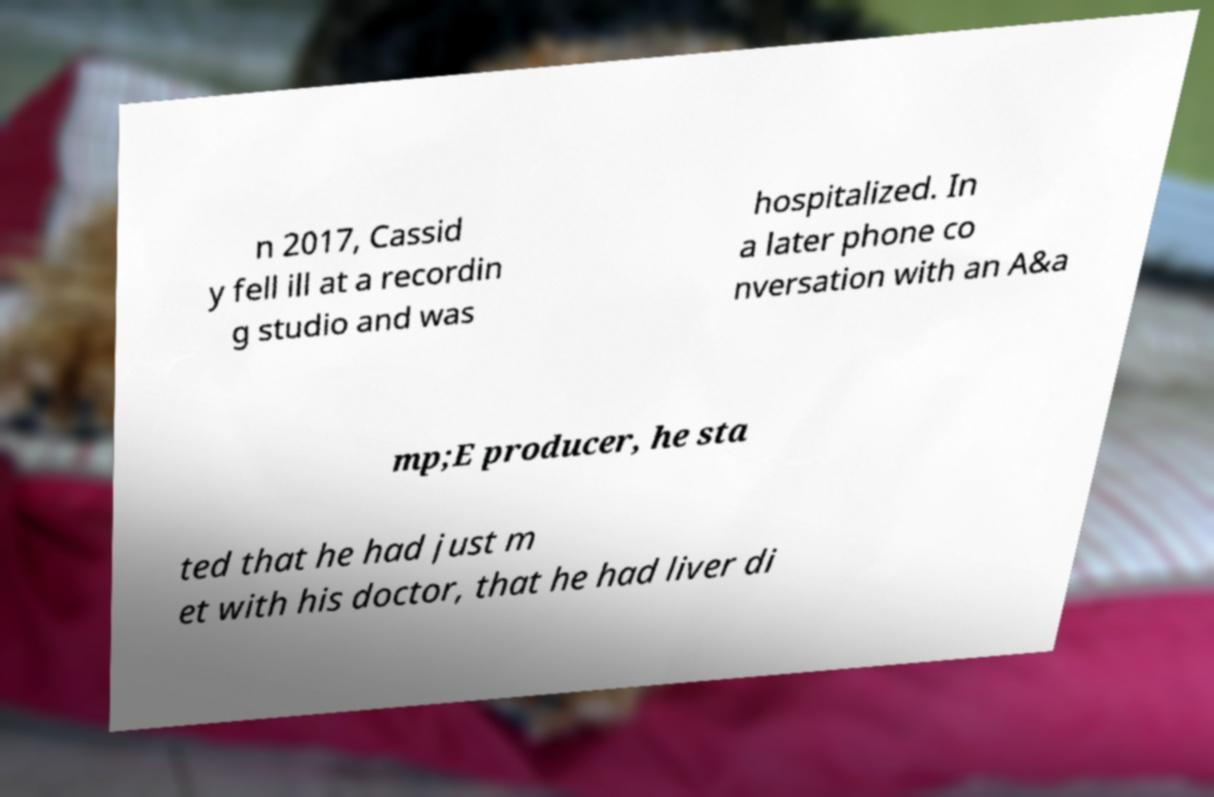There's text embedded in this image that I need extracted. Can you transcribe it verbatim? n 2017, Cassid y fell ill at a recordin g studio and was hospitalized. In a later phone co nversation with an A&a mp;E producer, he sta ted that he had just m et with his doctor, that he had liver di 